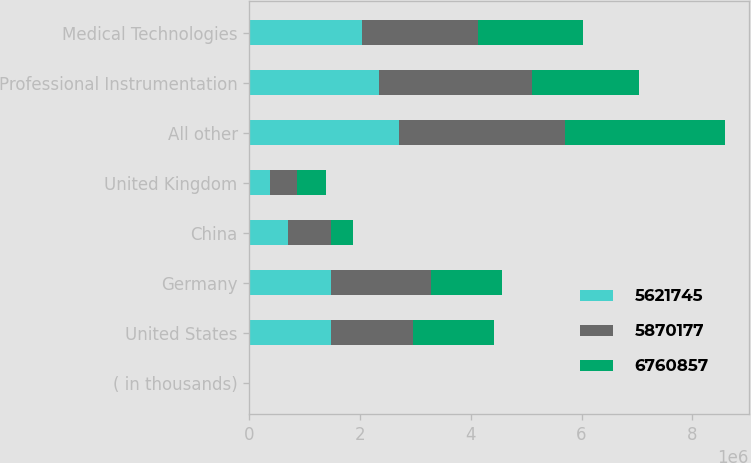Convert chart. <chart><loc_0><loc_0><loc_500><loc_500><stacked_bar_chart><ecel><fcel>( in thousands)<fcel>United States<fcel>Germany<fcel>China<fcel>United Kingdom<fcel>All other<fcel>Professional Instrumentation<fcel>Medical Technologies<nl><fcel>5.62174e+06<fcel>2009<fcel>1.47546e+06<fcel>1.47546e+06<fcel>702259<fcel>379013<fcel>2.70855e+06<fcel>2.34327e+06<fcel>2.02988e+06<nl><fcel>5.87018e+06<fcel>2008<fcel>1.47546e+06<fcel>1.7994e+06<fcel>771881<fcel>485823<fcel>2.99375e+06<fcel>2.75846e+06<fcel>2.1029e+06<nl><fcel>6.76086e+06<fcel>2007<fcel>1.47546e+06<fcel>1.29462e+06<fcel>397246<fcel>517495<fcel>2.88826e+06<fcel>1.93551e+06<fcel>1.88452e+06<nl></chart> 